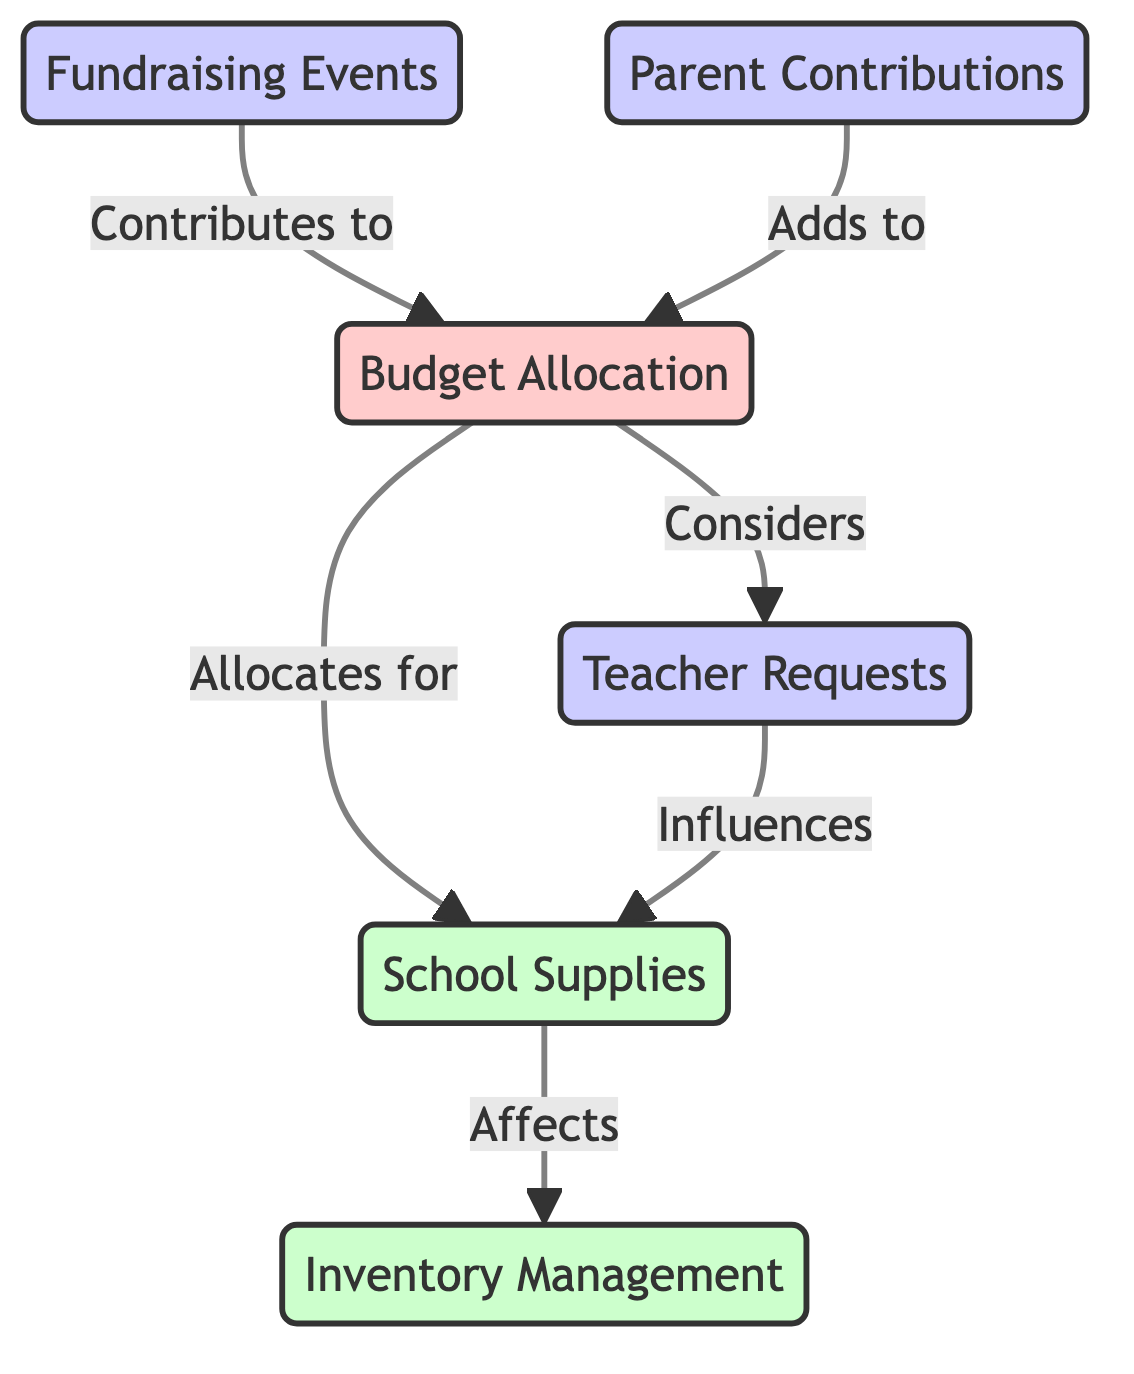What is the total number of nodes in the diagram? The diagram consists of six distinct nodes: Budget Allocation, School Supplies, Teacher Requests, Fundraising Events, Parent Contributions, and Inventory Management. Therefore, counting these gives a total of six nodes.
Answer: 6 What are the two types of input nodes in the diagram? The input nodes are Fundraising Events and Parent Contributions, which both contribute to Budget Allocation. These are the only two nodes classified as input in the diagram.
Answer: Fundraising Events, Parent Contributions Which node is allocated to first from Budget Allocation? Budget Allocation allocates funds specifically for School Supplies as indicated by the direct edge leading to it from Budget Allocation. This shows that the school supplies are a primary focus of the budget resources.
Answer: School Supplies How many edges are connected to Budget Allocation? Budget Allocation has four edges: one leading to School Supplies, one to Teacher Requests, and two incoming edges from Fundraising Events and Parent Contributions. Counting these indicates that Budget Allocation is a central node connected to four edges.
Answer: 4 Which node influences the supply allocation? The node that influences the allocation for School Supplies is Teacher Requests, as indicated by the edge leading from Teacher Requests to School Supplies in the diagram. This shows that what teachers request plays a significant role in determining what supplies are allocated.
Answer: Teacher Requests What is the relationship between School Supplies and Inventory Management? The relationship is that School Supplies affects Inventory Management, as shown by the directed edge leading from School Supplies to Inventory Management. This indicates that the acquired supplies have a direct impact on how inventory is managed in the school.
Answer: Affects What nodes contribute to Budget Allocation? Both Fundraising Events and Parent Contributions contribute resources to Budget Allocation, as indicated by the edges leading to Budget Allocation from these nodes. This illustrates the sources of funding for the school budget.
Answer: Fundraising Events, Parent Contributions How many nodes are output nodes in the diagram? There are two output nodes: School Supplies and Inventory Management, which are the end points of direct allocations from Budget Allocation and School Supplies, respectively. Thus, counting these nodes gives a total of two output nodes.
Answer: 2 Which node considers Teacher Requests? The node that considers Teacher Requests is Budget Allocation, as indicated by the edge going from Budget Allocation to Teacher Requests. This shows the decision-making process involved in budget considerations where teacher inputs are factored in.
Answer: Budget Allocation 